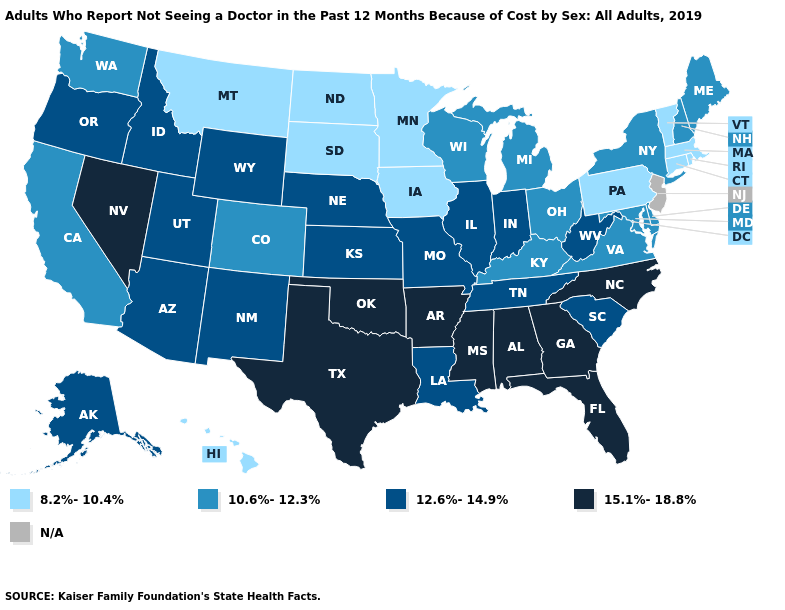Among the states that border Nevada , which have the highest value?
Be succinct. Arizona, Idaho, Oregon, Utah. Among the states that border Washington , which have the highest value?
Keep it brief. Idaho, Oregon. Which states have the lowest value in the MidWest?
Be succinct. Iowa, Minnesota, North Dakota, South Dakota. Among the states that border Florida , which have the lowest value?
Short answer required. Alabama, Georgia. Which states have the lowest value in the West?
Keep it brief. Hawaii, Montana. Name the states that have a value in the range 8.2%-10.4%?
Concise answer only. Connecticut, Hawaii, Iowa, Massachusetts, Minnesota, Montana, North Dakota, Pennsylvania, Rhode Island, South Dakota, Vermont. Does the first symbol in the legend represent the smallest category?
Be succinct. Yes. What is the value of Alaska?
Write a very short answer. 12.6%-14.9%. Name the states that have a value in the range 10.6%-12.3%?
Answer briefly. California, Colorado, Delaware, Kentucky, Maine, Maryland, Michigan, New Hampshire, New York, Ohio, Virginia, Washington, Wisconsin. What is the value of New Hampshire?
Give a very brief answer. 10.6%-12.3%. What is the value of New Jersey?
Concise answer only. N/A. Does Montana have the lowest value in the West?
Concise answer only. Yes. What is the value of Delaware?
Quick response, please. 10.6%-12.3%. Does South Dakota have the highest value in the MidWest?
Keep it brief. No. 